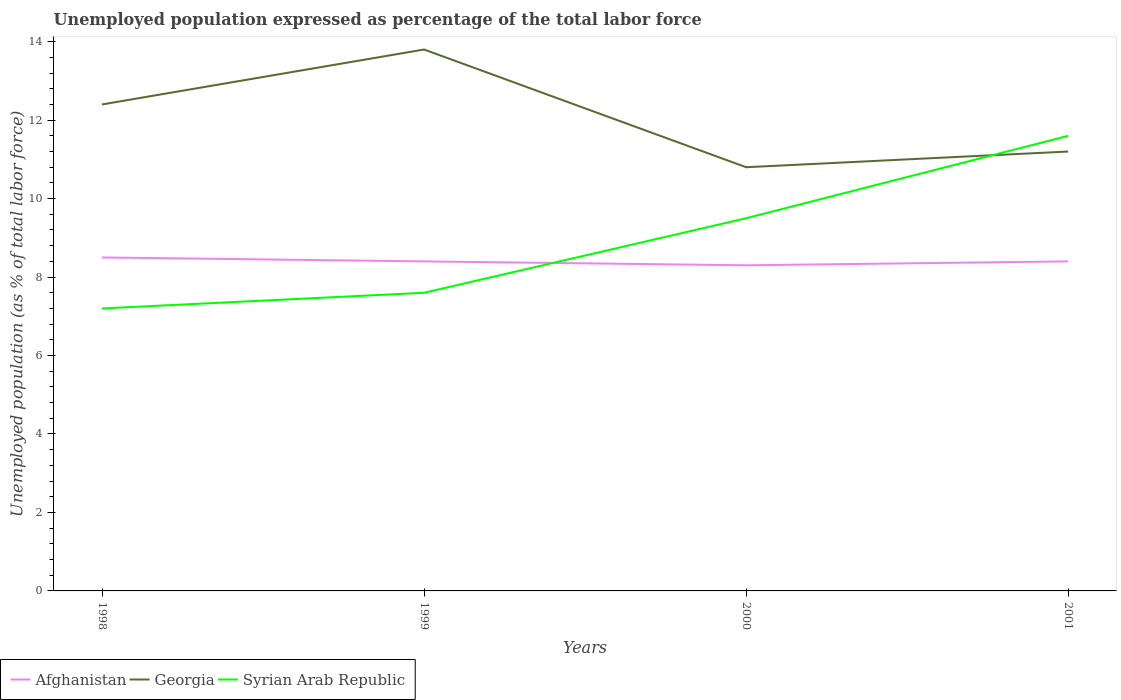Does the line corresponding to Georgia intersect with the line corresponding to Afghanistan?
Your answer should be compact. No. Is the number of lines equal to the number of legend labels?
Give a very brief answer. Yes. Across all years, what is the maximum unemployment in in Syrian Arab Republic?
Your answer should be compact. 7.2. What is the total unemployment in in Afghanistan in the graph?
Ensure brevity in your answer.  0.1. What is the difference between the highest and the second highest unemployment in in Syrian Arab Republic?
Provide a short and direct response. 4.4. What is the difference between the highest and the lowest unemployment in in Georgia?
Give a very brief answer. 2. Is the unemployment in in Georgia strictly greater than the unemployment in in Syrian Arab Republic over the years?
Your response must be concise. No. How many lines are there?
Make the answer very short. 3. What is the difference between two consecutive major ticks on the Y-axis?
Your answer should be compact. 2. What is the title of the graph?
Provide a succinct answer. Unemployed population expressed as percentage of the total labor force. What is the label or title of the Y-axis?
Offer a terse response. Unemployed population (as % of total labor force). What is the Unemployed population (as % of total labor force) in Georgia in 1998?
Your answer should be very brief. 12.4. What is the Unemployed population (as % of total labor force) of Syrian Arab Republic in 1998?
Offer a terse response. 7.2. What is the Unemployed population (as % of total labor force) of Afghanistan in 1999?
Keep it short and to the point. 8.4. What is the Unemployed population (as % of total labor force) of Georgia in 1999?
Offer a terse response. 13.8. What is the Unemployed population (as % of total labor force) of Syrian Arab Republic in 1999?
Make the answer very short. 7.6. What is the Unemployed population (as % of total labor force) in Afghanistan in 2000?
Your answer should be compact. 8.3. What is the Unemployed population (as % of total labor force) of Georgia in 2000?
Your response must be concise. 10.8. What is the Unemployed population (as % of total labor force) of Afghanistan in 2001?
Keep it short and to the point. 8.4. What is the Unemployed population (as % of total labor force) in Georgia in 2001?
Your answer should be very brief. 11.2. What is the Unemployed population (as % of total labor force) of Syrian Arab Republic in 2001?
Your answer should be compact. 11.6. Across all years, what is the maximum Unemployed population (as % of total labor force) of Afghanistan?
Your response must be concise. 8.5. Across all years, what is the maximum Unemployed population (as % of total labor force) in Georgia?
Your response must be concise. 13.8. Across all years, what is the maximum Unemployed population (as % of total labor force) in Syrian Arab Republic?
Provide a short and direct response. 11.6. Across all years, what is the minimum Unemployed population (as % of total labor force) of Afghanistan?
Your answer should be very brief. 8.3. Across all years, what is the minimum Unemployed population (as % of total labor force) of Georgia?
Provide a succinct answer. 10.8. Across all years, what is the minimum Unemployed population (as % of total labor force) in Syrian Arab Republic?
Offer a very short reply. 7.2. What is the total Unemployed population (as % of total labor force) in Afghanistan in the graph?
Offer a very short reply. 33.6. What is the total Unemployed population (as % of total labor force) of Georgia in the graph?
Your response must be concise. 48.2. What is the total Unemployed population (as % of total labor force) of Syrian Arab Republic in the graph?
Make the answer very short. 35.9. What is the difference between the Unemployed population (as % of total labor force) of Syrian Arab Republic in 1998 and that in 1999?
Give a very brief answer. -0.4. What is the difference between the Unemployed population (as % of total labor force) of Afghanistan in 1998 and that in 2001?
Your answer should be very brief. 0.1. What is the difference between the Unemployed population (as % of total labor force) of Georgia in 1998 and that in 2001?
Ensure brevity in your answer.  1.2. What is the difference between the Unemployed population (as % of total labor force) of Afghanistan in 1999 and that in 2000?
Your answer should be very brief. 0.1. What is the difference between the Unemployed population (as % of total labor force) of Georgia in 1999 and that in 2000?
Keep it short and to the point. 3. What is the difference between the Unemployed population (as % of total labor force) of Syrian Arab Republic in 1999 and that in 2000?
Provide a short and direct response. -1.9. What is the difference between the Unemployed population (as % of total labor force) in Afghanistan in 1999 and that in 2001?
Offer a very short reply. 0. What is the difference between the Unemployed population (as % of total labor force) in Georgia in 1999 and that in 2001?
Provide a short and direct response. 2.6. What is the difference between the Unemployed population (as % of total labor force) in Syrian Arab Republic in 1999 and that in 2001?
Ensure brevity in your answer.  -4. What is the difference between the Unemployed population (as % of total labor force) of Syrian Arab Republic in 2000 and that in 2001?
Your response must be concise. -2.1. What is the difference between the Unemployed population (as % of total labor force) in Afghanistan in 1998 and the Unemployed population (as % of total labor force) in Georgia in 1999?
Provide a succinct answer. -5.3. What is the difference between the Unemployed population (as % of total labor force) in Georgia in 1998 and the Unemployed population (as % of total labor force) in Syrian Arab Republic in 1999?
Provide a short and direct response. 4.8. What is the difference between the Unemployed population (as % of total labor force) of Afghanistan in 1998 and the Unemployed population (as % of total labor force) of Georgia in 2000?
Offer a very short reply. -2.3. What is the difference between the Unemployed population (as % of total labor force) of Afghanistan in 1998 and the Unemployed population (as % of total labor force) of Syrian Arab Republic in 2000?
Your response must be concise. -1. What is the difference between the Unemployed population (as % of total labor force) of Georgia in 1998 and the Unemployed population (as % of total labor force) of Syrian Arab Republic in 2000?
Your answer should be very brief. 2.9. What is the difference between the Unemployed population (as % of total labor force) of Afghanistan in 1998 and the Unemployed population (as % of total labor force) of Georgia in 2001?
Offer a very short reply. -2.7. What is the difference between the Unemployed population (as % of total labor force) of Georgia in 1998 and the Unemployed population (as % of total labor force) of Syrian Arab Republic in 2001?
Provide a succinct answer. 0.8. What is the difference between the Unemployed population (as % of total labor force) of Afghanistan in 1999 and the Unemployed population (as % of total labor force) of Georgia in 2000?
Give a very brief answer. -2.4. What is the difference between the Unemployed population (as % of total labor force) of Afghanistan in 1999 and the Unemployed population (as % of total labor force) of Syrian Arab Republic in 2000?
Offer a very short reply. -1.1. What is the difference between the Unemployed population (as % of total labor force) in Georgia in 1999 and the Unemployed population (as % of total labor force) in Syrian Arab Republic in 2000?
Your response must be concise. 4.3. What is the difference between the Unemployed population (as % of total labor force) of Afghanistan in 1999 and the Unemployed population (as % of total labor force) of Georgia in 2001?
Provide a short and direct response. -2.8. What is the average Unemployed population (as % of total labor force) of Georgia per year?
Make the answer very short. 12.05. What is the average Unemployed population (as % of total labor force) of Syrian Arab Republic per year?
Provide a succinct answer. 8.97. In the year 1998, what is the difference between the Unemployed population (as % of total labor force) in Afghanistan and Unemployed population (as % of total labor force) in Georgia?
Ensure brevity in your answer.  -3.9. In the year 1998, what is the difference between the Unemployed population (as % of total labor force) in Afghanistan and Unemployed population (as % of total labor force) in Syrian Arab Republic?
Your answer should be very brief. 1.3. In the year 1999, what is the difference between the Unemployed population (as % of total labor force) of Afghanistan and Unemployed population (as % of total labor force) of Georgia?
Provide a succinct answer. -5.4. In the year 1999, what is the difference between the Unemployed population (as % of total labor force) of Afghanistan and Unemployed population (as % of total labor force) of Syrian Arab Republic?
Offer a terse response. 0.8. In the year 1999, what is the difference between the Unemployed population (as % of total labor force) of Georgia and Unemployed population (as % of total labor force) of Syrian Arab Republic?
Keep it short and to the point. 6.2. In the year 2000, what is the difference between the Unemployed population (as % of total labor force) in Afghanistan and Unemployed population (as % of total labor force) in Georgia?
Offer a terse response. -2.5. In the year 2000, what is the difference between the Unemployed population (as % of total labor force) of Afghanistan and Unemployed population (as % of total labor force) of Syrian Arab Republic?
Provide a succinct answer. -1.2. In the year 2000, what is the difference between the Unemployed population (as % of total labor force) of Georgia and Unemployed population (as % of total labor force) of Syrian Arab Republic?
Your answer should be compact. 1.3. In the year 2001, what is the difference between the Unemployed population (as % of total labor force) in Afghanistan and Unemployed population (as % of total labor force) in Georgia?
Your response must be concise. -2.8. In the year 2001, what is the difference between the Unemployed population (as % of total labor force) of Afghanistan and Unemployed population (as % of total labor force) of Syrian Arab Republic?
Give a very brief answer. -3.2. In the year 2001, what is the difference between the Unemployed population (as % of total labor force) of Georgia and Unemployed population (as % of total labor force) of Syrian Arab Republic?
Provide a short and direct response. -0.4. What is the ratio of the Unemployed population (as % of total labor force) in Afghanistan in 1998 to that in 1999?
Keep it short and to the point. 1.01. What is the ratio of the Unemployed population (as % of total labor force) in Georgia in 1998 to that in 1999?
Your answer should be very brief. 0.9. What is the ratio of the Unemployed population (as % of total labor force) in Afghanistan in 1998 to that in 2000?
Your response must be concise. 1.02. What is the ratio of the Unemployed population (as % of total labor force) of Georgia in 1998 to that in 2000?
Provide a short and direct response. 1.15. What is the ratio of the Unemployed population (as % of total labor force) in Syrian Arab Republic in 1998 to that in 2000?
Offer a very short reply. 0.76. What is the ratio of the Unemployed population (as % of total labor force) in Afghanistan in 1998 to that in 2001?
Provide a short and direct response. 1.01. What is the ratio of the Unemployed population (as % of total labor force) of Georgia in 1998 to that in 2001?
Your response must be concise. 1.11. What is the ratio of the Unemployed population (as % of total labor force) in Syrian Arab Republic in 1998 to that in 2001?
Your answer should be very brief. 0.62. What is the ratio of the Unemployed population (as % of total labor force) in Afghanistan in 1999 to that in 2000?
Give a very brief answer. 1.01. What is the ratio of the Unemployed population (as % of total labor force) of Georgia in 1999 to that in 2000?
Offer a terse response. 1.28. What is the ratio of the Unemployed population (as % of total labor force) of Syrian Arab Republic in 1999 to that in 2000?
Your answer should be very brief. 0.8. What is the ratio of the Unemployed population (as % of total labor force) in Afghanistan in 1999 to that in 2001?
Give a very brief answer. 1. What is the ratio of the Unemployed population (as % of total labor force) of Georgia in 1999 to that in 2001?
Your answer should be very brief. 1.23. What is the ratio of the Unemployed population (as % of total labor force) in Syrian Arab Republic in 1999 to that in 2001?
Keep it short and to the point. 0.66. What is the ratio of the Unemployed population (as % of total labor force) in Afghanistan in 2000 to that in 2001?
Your response must be concise. 0.99. What is the ratio of the Unemployed population (as % of total labor force) of Georgia in 2000 to that in 2001?
Your answer should be compact. 0.96. What is the ratio of the Unemployed population (as % of total labor force) of Syrian Arab Republic in 2000 to that in 2001?
Offer a very short reply. 0.82. What is the difference between the highest and the lowest Unemployed population (as % of total labor force) of Afghanistan?
Provide a succinct answer. 0.2. 